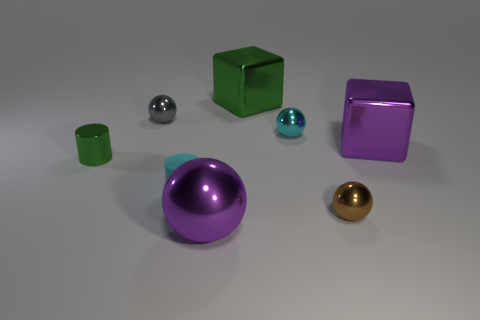Subtract all small gray metallic balls. How many balls are left? 3 Subtract all cylinders. How many objects are left? 6 Subtract 1 balls. How many balls are left? 3 Add 2 metallic spheres. How many objects exist? 10 Subtract all cyan balls. How many balls are left? 3 Subtract 1 cyan balls. How many objects are left? 7 Subtract all gray spheres. Subtract all yellow blocks. How many spheres are left? 3 Subtract all cyan balls. How many red cylinders are left? 0 Subtract all big yellow metallic objects. Subtract all tiny green things. How many objects are left? 7 Add 5 tiny gray objects. How many tiny gray objects are left? 6 